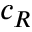Convert formula to latex. <formula><loc_0><loc_0><loc_500><loc_500>c _ { R }</formula> 